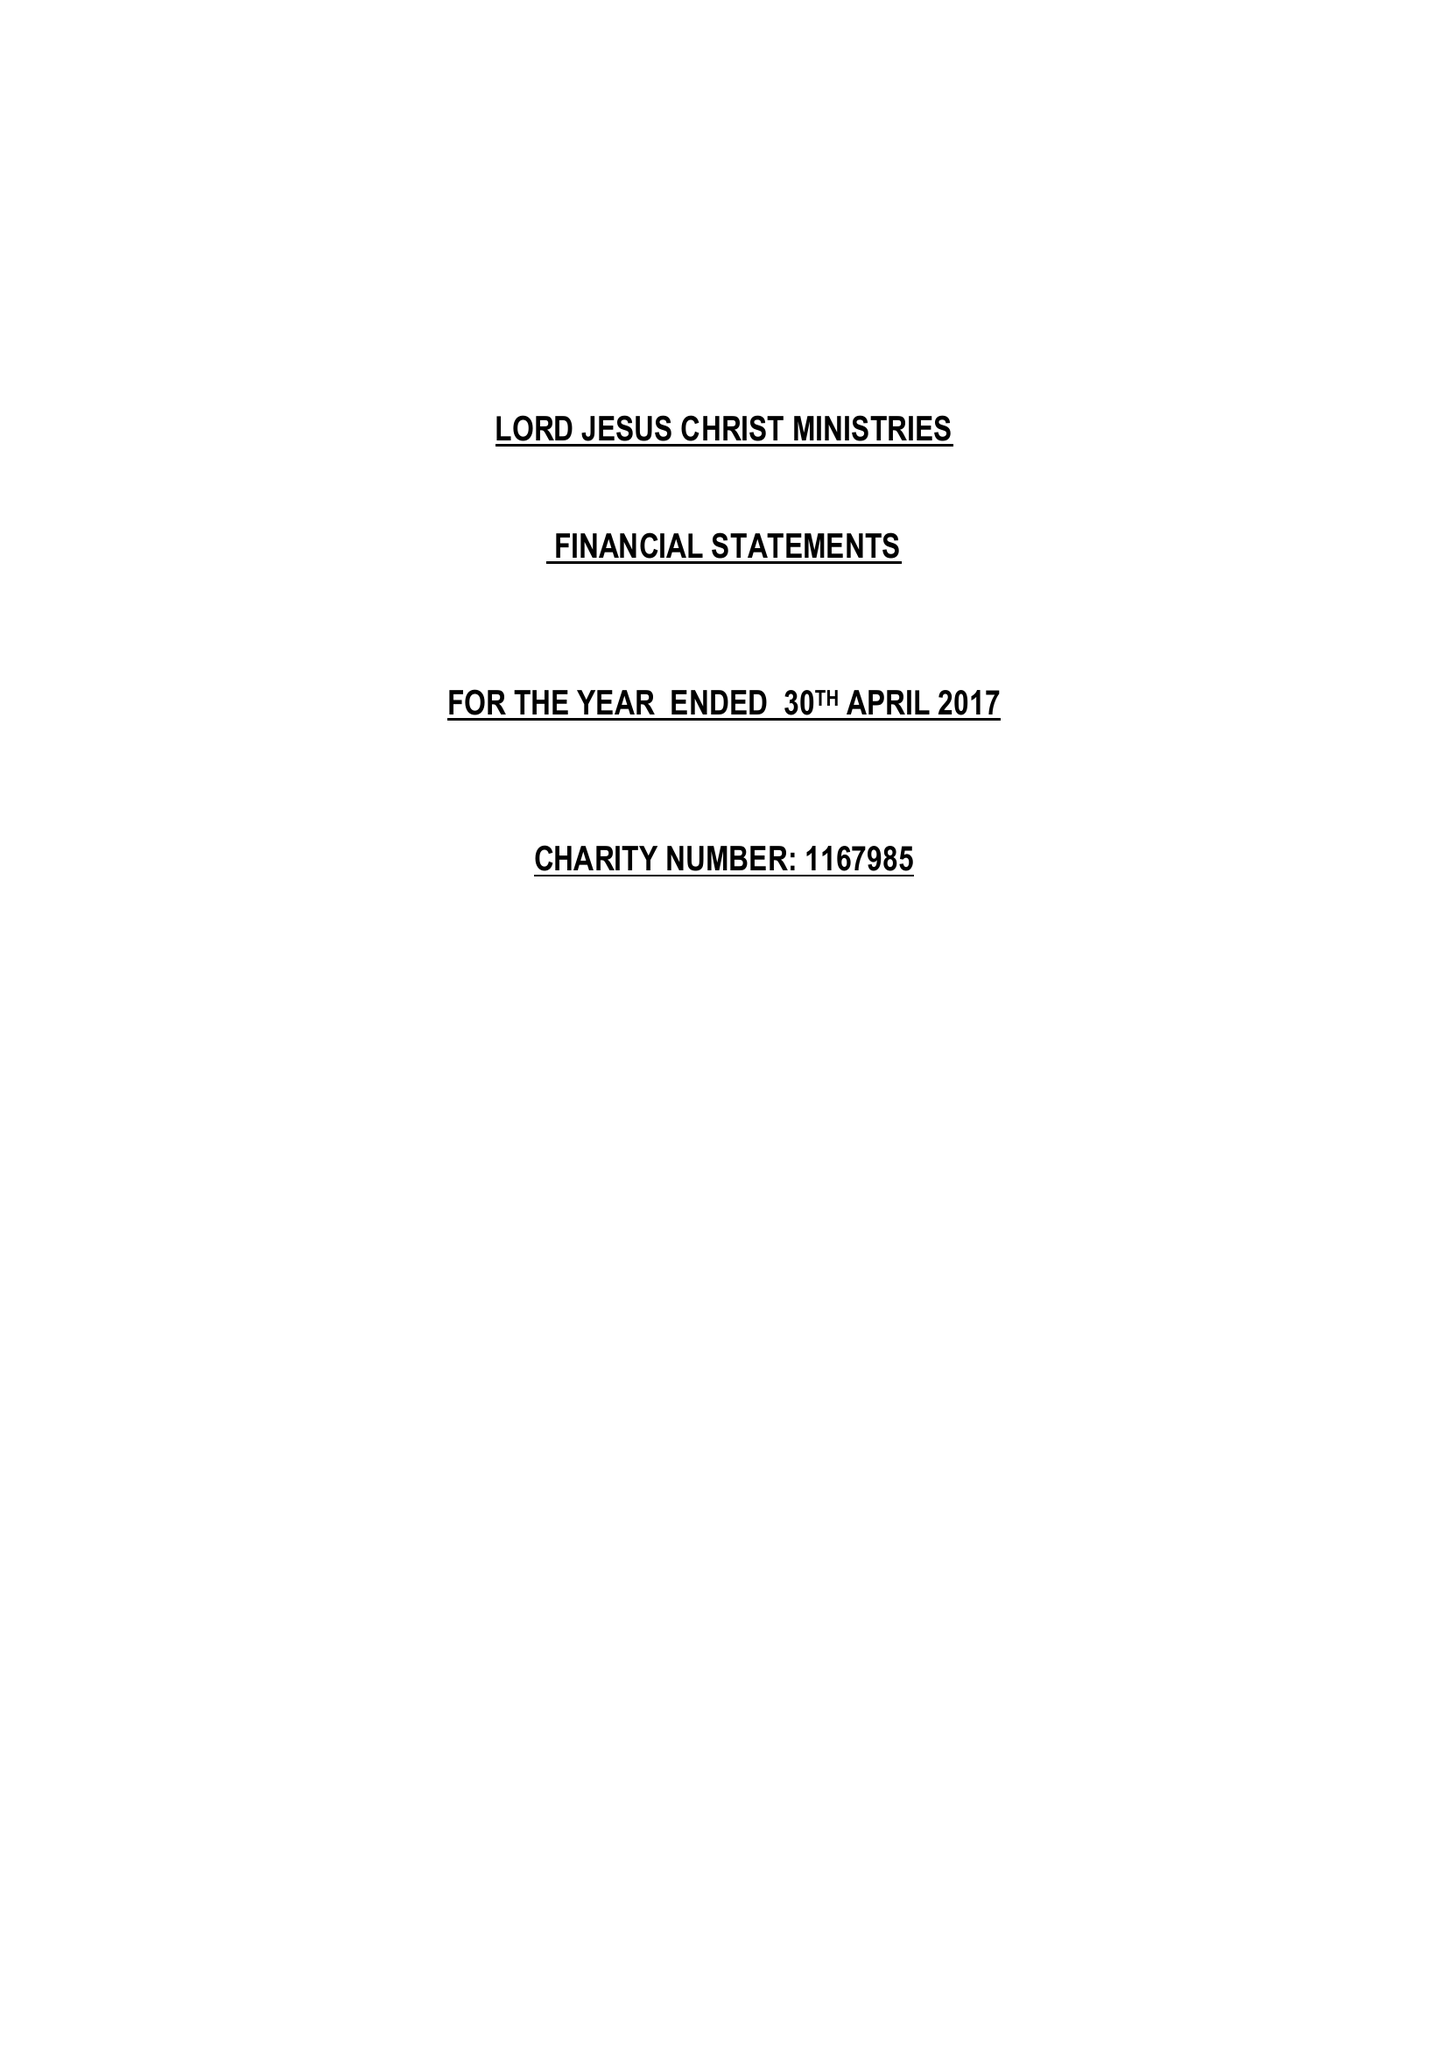What is the value for the charity_name?
Answer the question using a single word or phrase. Lord Jesus Christ Ministries 